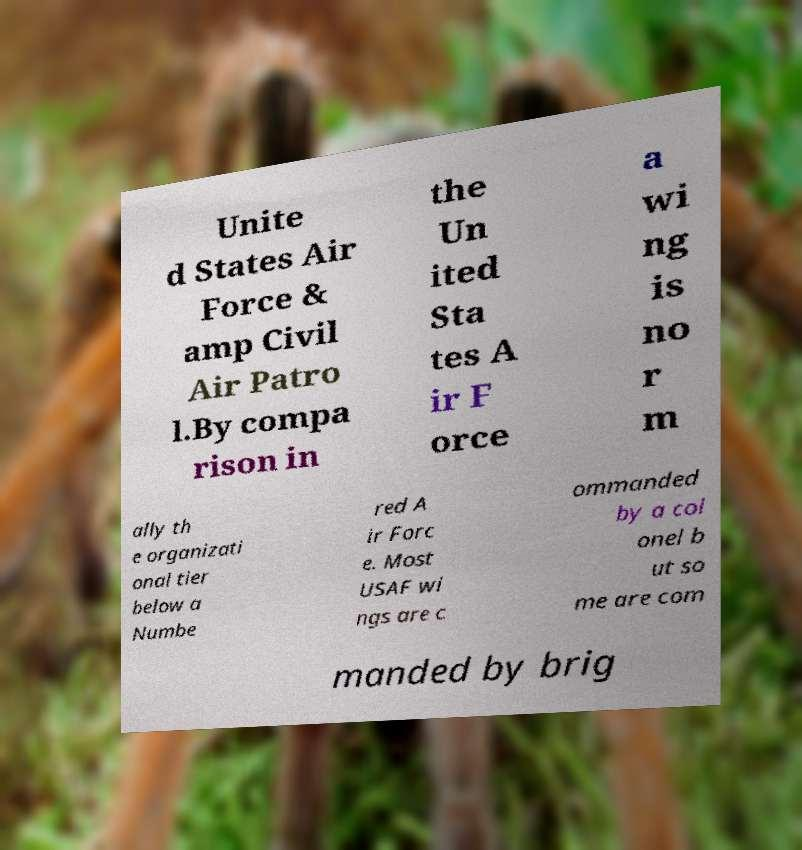Can you read and provide the text displayed in the image?This photo seems to have some interesting text. Can you extract and type it out for me? Unite d States Air Force & amp Civil Air Patro l.By compa rison in the Un ited Sta tes A ir F orce a wi ng is no r m ally th e organizati onal tier below a Numbe red A ir Forc e. Most USAF wi ngs are c ommanded by a col onel b ut so me are com manded by brig 